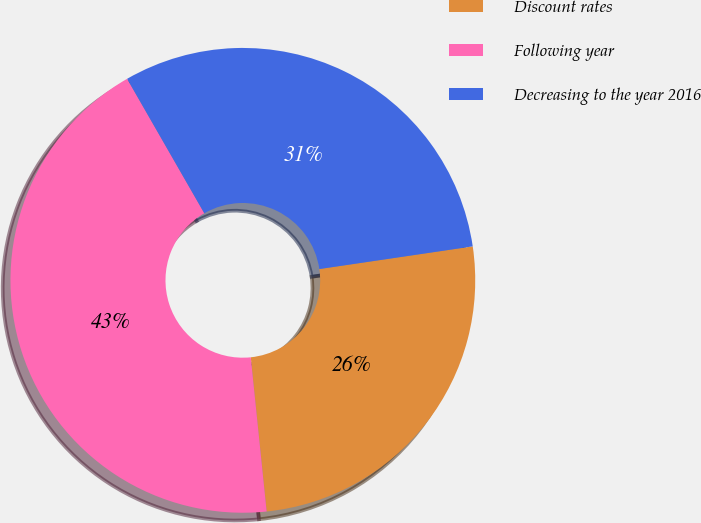Convert chart. <chart><loc_0><loc_0><loc_500><loc_500><pie_chart><fcel>Discount rates<fcel>Following year<fcel>Decreasing to the year 2016<nl><fcel>25.7%<fcel>43.34%<fcel>30.96%<nl></chart> 